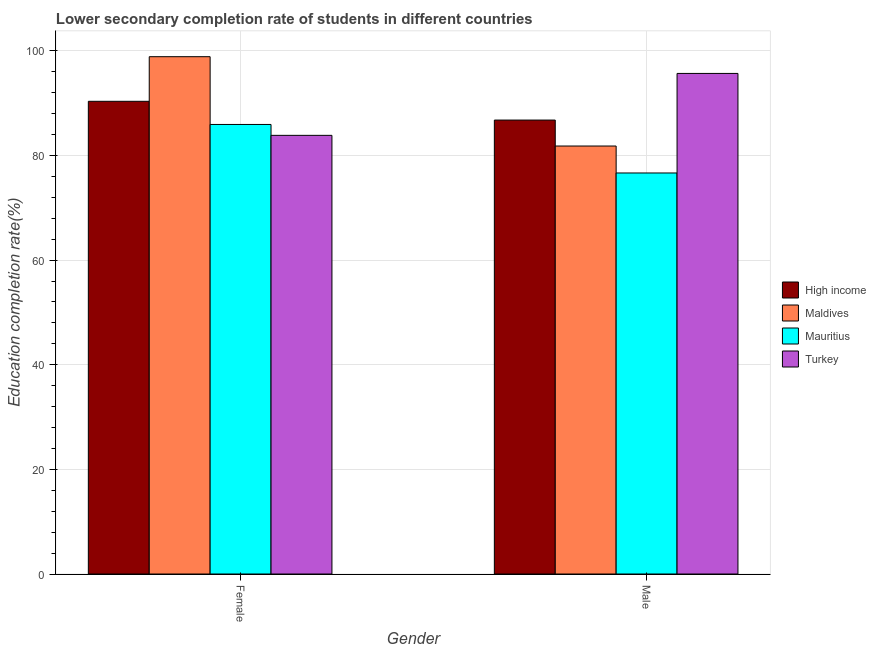How many different coloured bars are there?
Your answer should be compact. 4. Are the number of bars per tick equal to the number of legend labels?
Offer a terse response. Yes. Are the number of bars on each tick of the X-axis equal?
Offer a terse response. Yes. How many bars are there on the 2nd tick from the left?
Keep it short and to the point. 4. How many bars are there on the 2nd tick from the right?
Give a very brief answer. 4. What is the label of the 1st group of bars from the left?
Keep it short and to the point. Female. What is the education completion rate of male students in Turkey?
Offer a very short reply. 95.69. Across all countries, what is the maximum education completion rate of male students?
Keep it short and to the point. 95.69. Across all countries, what is the minimum education completion rate of male students?
Provide a succinct answer. 76.66. In which country was the education completion rate of female students minimum?
Provide a succinct answer. Turkey. What is the total education completion rate of female students in the graph?
Keep it short and to the point. 359.05. What is the difference between the education completion rate of male students in Turkey and that in Maldives?
Give a very brief answer. 13.88. What is the difference between the education completion rate of female students in High income and the education completion rate of male students in Maldives?
Keep it short and to the point. 8.55. What is the average education completion rate of male students per country?
Give a very brief answer. 85.24. What is the difference between the education completion rate of male students and education completion rate of female students in High income?
Keep it short and to the point. -3.59. What is the ratio of the education completion rate of male students in Turkey to that in Mauritius?
Offer a terse response. 1.25. What does the 4th bar from the left in Female represents?
Your answer should be very brief. Turkey. What does the 4th bar from the right in Male represents?
Provide a succinct answer. High income. What is the difference between two consecutive major ticks on the Y-axis?
Provide a short and direct response. 20. Are the values on the major ticks of Y-axis written in scientific E-notation?
Give a very brief answer. No. Does the graph contain any zero values?
Ensure brevity in your answer.  No. Where does the legend appear in the graph?
Your answer should be compact. Center right. How many legend labels are there?
Offer a very short reply. 4. What is the title of the graph?
Give a very brief answer. Lower secondary completion rate of students in different countries. Does "Cayman Islands" appear as one of the legend labels in the graph?
Provide a short and direct response. No. What is the label or title of the X-axis?
Your answer should be very brief. Gender. What is the label or title of the Y-axis?
Provide a succinct answer. Education completion rate(%). What is the Education completion rate(%) in High income in Female?
Offer a terse response. 90.36. What is the Education completion rate(%) of Maldives in Female?
Give a very brief answer. 98.89. What is the Education completion rate(%) of Mauritius in Female?
Keep it short and to the point. 85.94. What is the Education completion rate(%) of Turkey in Female?
Your answer should be compact. 83.86. What is the Education completion rate(%) in High income in Male?
Provide a succinct answer. 86.78. What is the Education completion rate(%) of Maldives in Male?
Your answer should be compact. 81.82. What is the Education completion rate(%) of Mauritius in Male?
Your answer should be compact. 76.66. What is the Education completion rate(%) of Turkey in Male?
Your answer should be very brief. 95.69. Across all Gender, what is the maximum Education completion rate(%) of High income?
Offer a very short reply. 90.36. Across all Gender, what is the maximum Education completion rate(%) in Maldives?
Provide a succinct answer. 98.89. Across all Gender, what is the maximum Education completion rate(%) of Mauritius?
Offer a terse response. 85.94. Across all Gender, what is the maximum Education completion rate(%) in Turkey?
Provide a short and direct response. 95.69. Across all Gender, what is the minimum Education completion rate(%) of High income?
Your response must be concise. 86.78. Across all Gender, what is the minimum Education completion rate(%) in Maldives?
Provide a short and direct response. 81.82. Across all Gender, what is the minimum Education completion rate(%) in Mauritius?
Your answer should be very brief. 76.66. Across all Gender, what is the minimum Education completion rate(%) in Turkey?
Offer a very short reply. 83.86. What is the total Education completion rate(%) of High income in the graph?
Your response must be concise. 177.14. What is the total Education completion rate(%) of Maldives in the graph?
Ensure brevity in your answer.  180.71. What is the total Education completion rate(%) in Mauritius in the graph?
Ensure brevity in your answer.  162.6. What is the total Education completion rate(%) of Turkey in the graph?
Offer a very short reply. 179.55. What is the difference between the Education completion rate(%) of High income in Female and that in Male?
Offer a terse response. 3.59. What is the difference between the Education completion rate(%) of Maldives in Female and that in Male?
Provide a succinct answer. 17.08. What is the difference between the Education completion rate(%) of Mauritius in Female and that in Male?
Your response must be concise. 9.27. What is the difference between the Education completion rate(%) of Turkey in Female and that in Male?
Offer a very short reply. -11.84. What is the difference between the Education completion rate(%) in High income in Female and the Education completion rate(%) in Maldives in Male?
Provide a succinct answer. 8.55. What is the difference between the Education completion rate(%) of High income in Female and the Education completion rate(%) of Mauritius in Male?
Provide a succinct answer. 13.7. What is the difference between the Education completion rate(%) in High income in Female and the Education completion rate(%) in Turkey in Male?
Keep it short and to the point. -5.33. What is the difference between the Education completion rate(%) in Maldives in Female and the Education completion rate(%) in Mauritius in Male?
Provide a short and direct response. 22.23. What is the difference between the Education completion rate(%) in Mauritius in Female and the Education completion rate(%) in Turkey in Male?
Your answer should be very brief. -9.76. What is the average Education completion rate(%) in High income per Gender?
Your answer should be compact. 88.57. What is the average Education completion rate(%) in Maldives per Gender?
Give a very brief answer. 90.35. What is the average Education completion rate(%) of Mauritius per Gender?
Provide a short and direct response. 81.3. What is the average Education completion rate(%) of Turkey per Gender?
Keep it short and to the point. 89.77. What is the difference between the Education completion rate(%) of High income and Education completion rate(%) of Maldives in Female?
Your response must be concise. -8.53. What is the difference between the Education completion rate(%) of High income and Education completion rate(%) of Mauritius in Female?
Make the answer very short. 4.43. What is the difference between the Education completion rate(%) in High income and Education completion rate(%) in Turkey in Female?
Provide a short and direct response. 6.51. What is the difference between the Education completion rate(%) of Maldives and Education completion rate(%) of Mauritius in Female?
Keep it short and to the point. 12.96. What is the difference between the Education completion rate(%) of Maldives and Education completion rate(%) of Turkey in Female?
Keep it short and to the point. 15.04. What is the difference between the Education completion rate(%) of Mauritius and Education completion rate(%) of Turkey in Female?
Your answer should be very brief. 2.08. What is the difference between the Education completion rate(%) of High income and Education completion rate(%) of Maldives in Male?
Your answer should be very brief. 4.96. What is the difference between the Education completion rate(%) in High income and Education completion rate(%) in Mauritius in Male?
Give a very brief answer. 10.12. What is the difference between the Education completion rate(%) in High income and Education completion rate(%) in Turkey in Male?
Keep it short and to the point. -8.92. What is the difference between the Education completion rate(%) in Maldives and Education completion rate(%) in Mauritius in Male?
Provide a short and direct response. 5.15. What is the difference between the Education completion rate(%) of Maldives and Education completion rate(%) of Turkey in Male?
Provide a short and direct response. -13.88. What is the difference between the Education completion rate(%) of Mauritius and Education completion rate(%) of Turkey in Male?
Make the answer very short. -19.03. What is the ratio of the Education completion rate(%) in High income in Female to that in Male?
Make the answer very short. 1.04. What is the ratio of the Education completion rate(%) in Maldives in Female to that in Male?
Give a very brief answer. 1.21. What is the ratio of the Education completion rate(%) of Mauritius in Female to that in Male?
Keep it short and to the point. 1.12. What is the ratio of the Education completion rate(%) of Turkey in Female to that in Male?
Keep it short and to the point. 0.88. What is the difference between the highest and the second highest Education completion rate(%) in High income?
Offer a terse response. 3.59. What is the difference between the highest and the second highest Education completion rate(%) in Maldives?
Your answer should be compact. 17.08. What is the difference between the highest and the second highest Education completion rate(%) of Mauritius?
Ensure brevity in your answer.  9.27. What is the difference between the highest and the second highest Education completion rate(%) of Turkey?
Give a very brief answer. 11.84. What is the difference between the highest and the lowest Education completion rate(%) of High income?
Provide a succinct answer. 3.59. What is the difference between the highest and the lowest Education completion rate(%) of Maldives?
Your response must be concise. 17.08. What is the difference between the highest and the lowest Education completion rate(%) of Mauritius?
Offer a terse response. 9.27. What is the difference between the highest and the lowest Education completion rate(%) in Turkey?
Make the answer very short. 11.84. 